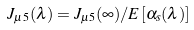Convert formula to latex. <formula><loc_0><loc_0><loc_500><loc_500>J _ { \mu 5 } ( \lambda ) = J _ { \mu 5 } ( \infty ) / E [ \alpha _ { s } ( \lambda ) ]</formula> 